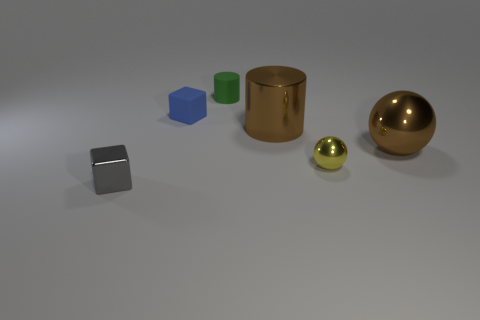What is the color of the tiny cube that is in front of the tiny shiny object that is on the right side of the small gray block?
Offer a very short reply. Gray. What number of tiny metallic blocks have the same color as the large ball?
Give a very brief answer. 0. There is a large cylinder; is it the same color as the small metal object that is to the right of the blue rubber block?
Offer a very short reply. No. Are there fewer tiny blue cubes than brown things?
Give a very brief answer. Yes. Are there more gray shiny objects that are behind the tiny green cylinder than brown balls that are left of the yellow metallic ball?
Your answer should be compact. No. Is the material of the small green cylinder the same as the large brown ball?
Your answer should be very brief. No. There is a small block on the right side of the small gray object; how many brown balls are on the right side of it?
Provide a short and direct response. 1. There is a block that is behind the gray object; is its color the same as the metal block?
Provide a short and direct response. No. How many things are tiny rubber objects or tiny cubes that are in front of the large metallic cylinder?
Give a very brief answer. 3. There is a small object that is to the right of the green rubber object; is it the same shape as the rubber object in front of the small green cylinder?
Provide a short and direct response. No. 